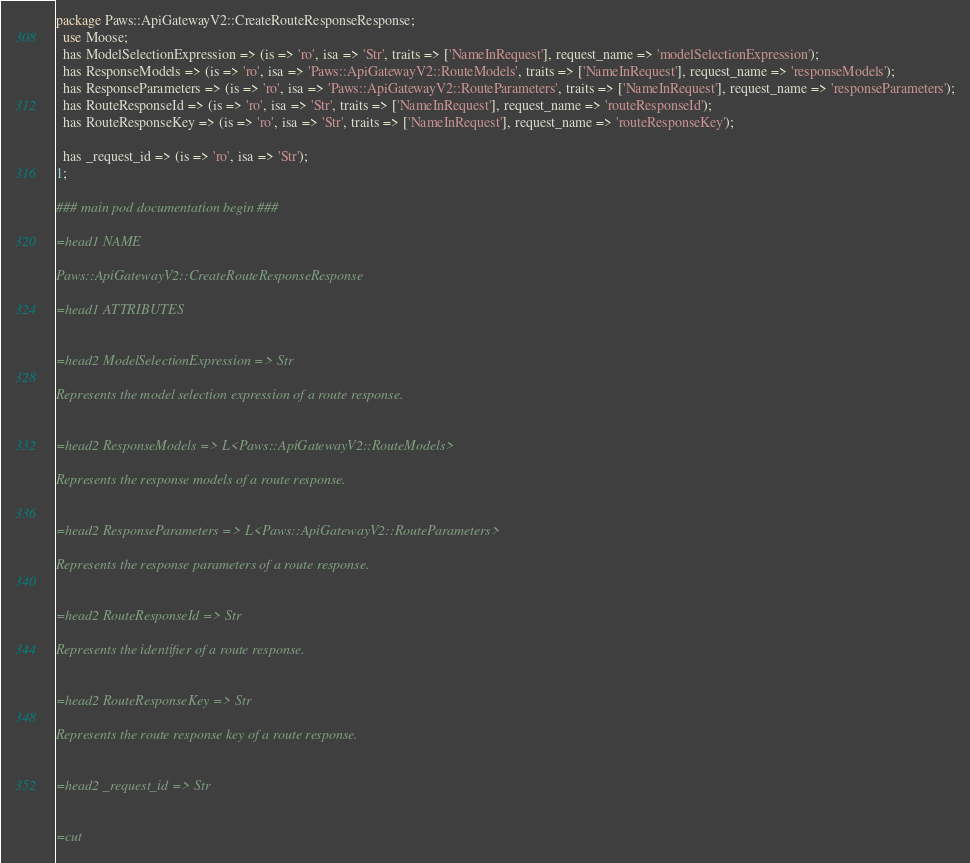Convert code to text. <code><loc_0><loc_0><loc_500><loc_500><_Perl_>
package Paws::ApiGatewayV2::CreateRouteResponseResponse;
  use Moose;
  has ModelSelectionExpression => (is => 'ro', isa => 'Str', traits => ['NameInRequest'], request_name => 'modelSelectionExpression');
  has ResponseModels => (is => 'ro', isa => 'Paws::ApiGatewayV2::RouteModels', traits => ['NameInRequest'], request_name => 'responseModels');
  has ResponseParameters => (is => 'ro', isa => 'Paws::ApiGatewayV2::RouteParameters', traits => ['NameInRequest'], request_name => 'responseParameters');
  has RouteResponseId => (is => 'ro', isa => 'Str', traits => ['NameInRequest'], request_name => 'routeResponseId');
  has RouteResponseKey => (is => 'ro', isa => 'Str', traits => ['NameInRequest'], request_name => 'routeResponseKey');

  has _request_id => (is => 'ro', isa => 'Str');
1;

### main pod documentation begin ###

=head1 NAME

Paws::ApiGatewayV2::CreateRouteResponseResponse

=head1 ATTRIBUTES


=head2 ModelSelectionExpression => Str

Represents the model selection expression of a route response.


=head2 ResponseModels => L<Paws::ApiGatewayV2::RouteModels>

Represents the response models of a route response.


=head2 ResponseParameters => L<Paws::ApiGatewayV2::RouteParameters>

Represents the response parameters of a route response.


=head2 RouteResponseId => Str

Represents the identifier of a route response.


=head2 RouteResponseKey => Str

Represents the route response key of a route response.


=head2 _request_id => Str


=cut

</code> 